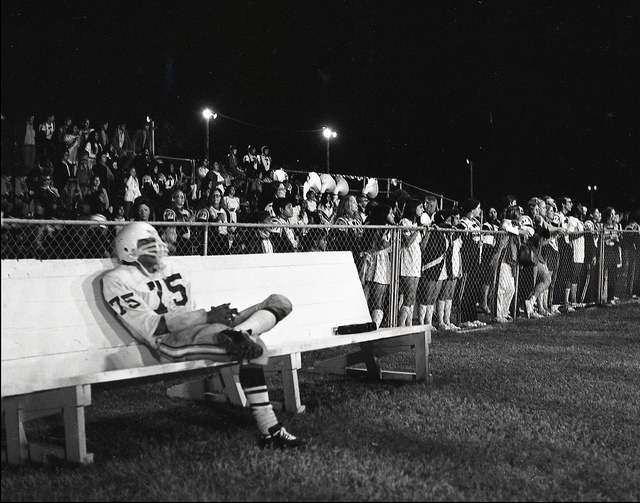Please identify all text content in this image. 75 75 